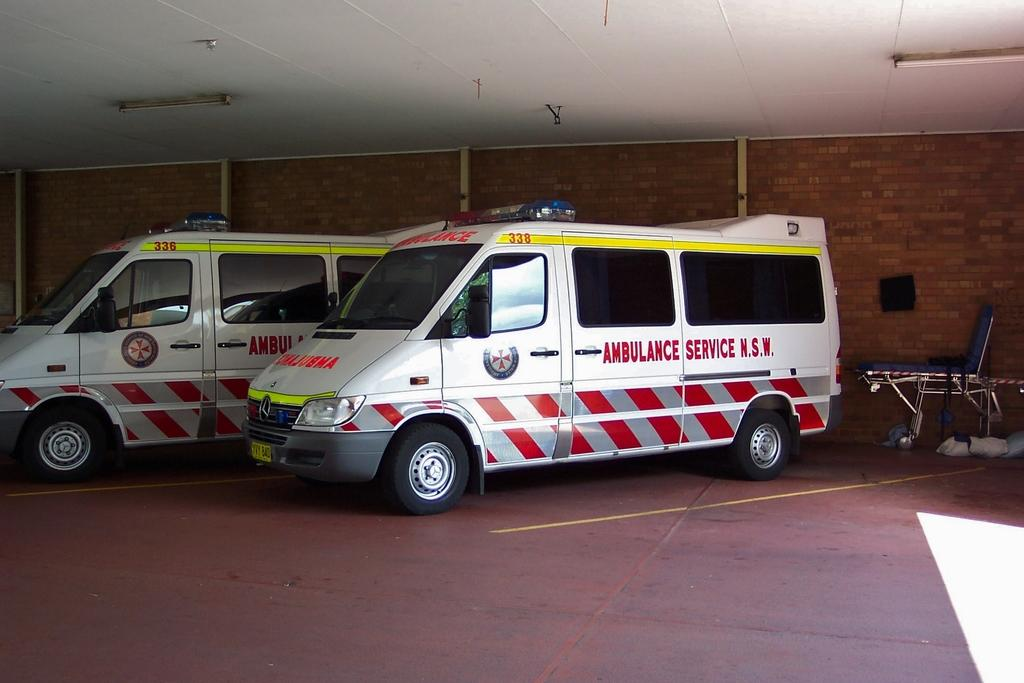<image>
Give a short and clear explanation of the subsequent image. A white ambulance with red and silver stripes on it in N.S.W. 